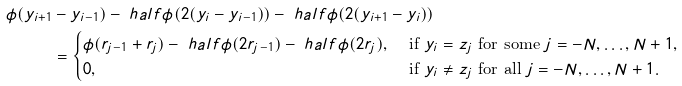<formula> <loc_0><loc_0><loc_500><loc_500>\phi ( y _ { i + 1 } & - y _ { i - 1 } ) - \ h a l f \phi ( 2 ( y _ { i } - y _ { i - 1 } ) ) - \ h a l f \phi ( 2 ( y _ { i + 1 } - y _ { i } ) ) \\ & = \begin{cases} \phi ( r _ { j - 1 } + r _ { j } ) - \ h a l f \phi ( 2 r _ { j - 1 } ) - \ h a l f \phi ( 2 r _ { j } ) , & \text { if } y _ { i } = z _ { j } \text { for some } j = - N , \dots , N + 1 , \\ 0 , & \text { if } y _ { i } \ne z _ { j } \text { for all } j = - N , \dots , N + 1 . \end{cases}</formula> 